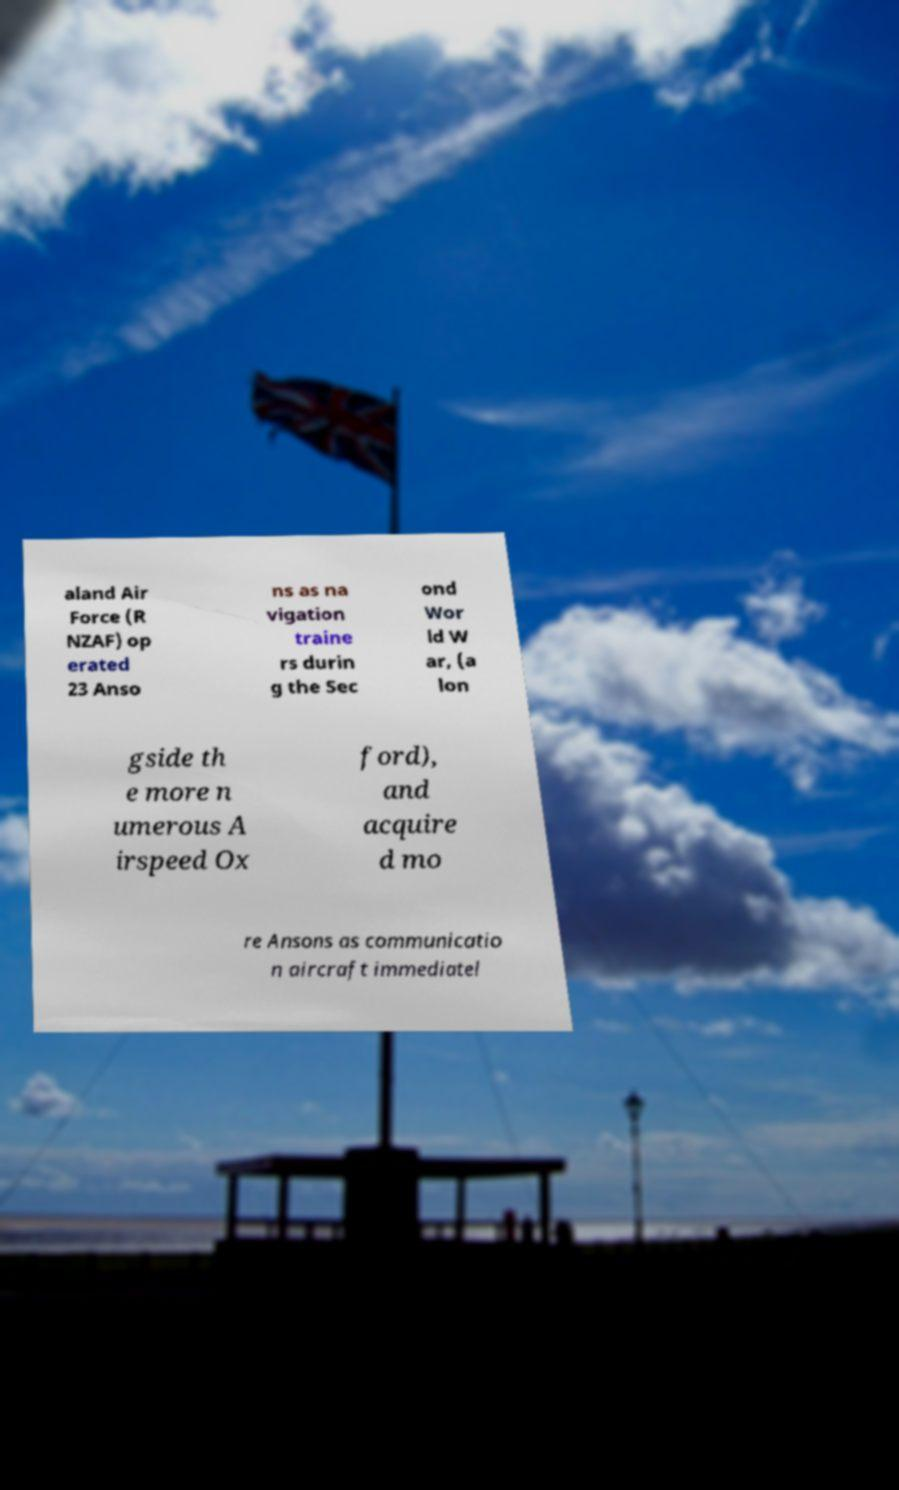For documentation purposes, I need the text within this image transcribed. Could you provide that? aland Air Force (R NZAF) op erated 23 Anso ns as na vigation traine rs durin g the Sec ond Wor ld W ar, (a lon gside th e more n umerous A irspeed Ox ford), and acquire d mo re Ansons as communicatio n aircraft immediatel 